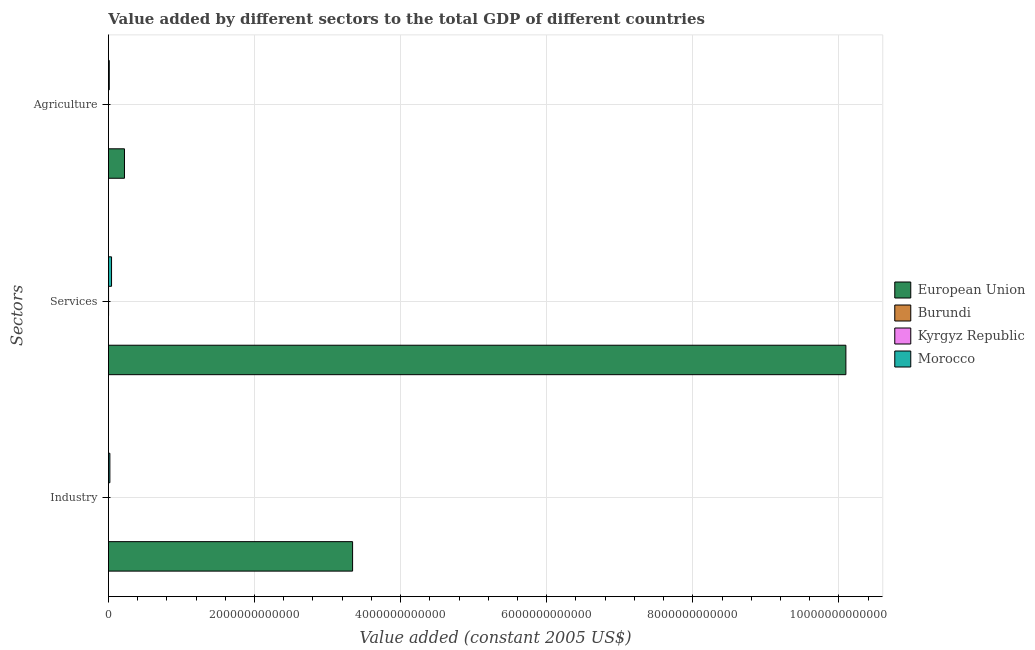How many groups of bars are there?
Offer a very short reply. 3. Are the number of bars per tick equal to the number of legend labels?
Ensure brevity in your answer.  Yes. Are the number of bars on each tick of the Y-axis equal?
Give a very brief answer. Yes. What is the label of the 2nd group of bars from the top?
Offer a very short reply. Services. What is the value added by agricultural sector in Morocco?
Keep it short and to the point. 1.14e+1. Across all countries, what is the maximum value added by industrial sector?
Your answer should be very brief. 3.34e+12. Across all countries, what is the minimum value added by industrial sector?
Offer a terse response. 2.58e+08. In which country was the value added by agricultural sector minimum?
Give a very brief answer. Burundi. What is the total value added by industrial sector in the graph?
Offer a terse response. 3.36e+12. What is the difference between the value added by services in Morocco and that in Kyrgyz Republic?
Ensure brevity in your answer.  4.08e+1. What is the difference between the value added by industrial sector in Kyrgyz Republic and the value added by agricultural sector in European Union?
Give a very brief answer. -2.19e+11. What is the average value added by services per country?
Offer a very short reply. 2.54e+12. What is the difference between the value added by services and value added by industrial sector in Kyrgyz Republic?
Your answer should be very brief. 1.25e+09. In how many countries, is the value added by agricultural sector greater than 6400000000000 US$?
Offer a very short reply. 0. What is the ratio of the value added by industrial sector in European Union to that in Morocco?
Keep it short and to the point. 169.88. Is the value added by industrial sector in Morocco less than that in Burundi?
Your response must be concise. No. What is the difference between the highest and the second highest value added by industrial sector?
Make the answer very short. 3.32e+12. What is the difference between the highest and the lowest value added by agricultural sector?
Make the answer very short. 2.19e+11. What does the 3rd bar from the top in Services represents?
Offer a terse response. Burundi. What does the 4th bar from the bottom in Industry represents?
Provide a short and direct response. Morocco. How many bars are there?
Your answer should be very brief. 12. What is the difference between two consecutive major ticks on the X-axis?
Give a very brief answer. 2.00e+12. Are the values on the major ticks of X-axis written in scientific E-notation?
Your answer should be compact. No. Does the graph contain any zero values?
Your response must be concise. No. Does the graph contain grids?
Offer a terse response. Yes. Where does the legend appear in the graph?
Your response must be concise. Center right. How many legend labels are there?
Ensure brevity in your answer.  4. How are the legend labels stacked?
Your answer should be compact. Vertical. What is the title of the graph?
Your answer should be very brief. Value added by different sectors to the total GDP of different countries. What is the label or title of the X-axis?
Provide a short and direct response. Value added (constant 2005 US$). What is the label or title of the Y-axis?
Your response must be concise. Sectors. What is the Value added (constant 2005 US$) of European Union in Industry?
Ensure brevity in your answer.  3.34e+12. What is the Value added (constant 2005 US$) in Burundi in Industry?
Keep it short and to the point. 2.58e+08. What is the Value added (constant 2005 US$) of Kyrgyz Republic in Industry?
Keep it short and to the point. 5.54e+08. What is the Value added (constant 2005 US$) of Morocco in Industry?
Your answer should be very brief. 1.97e+1. What is the Value added (constant 2005 US$) in European Union in Services?
Keep it short and to the point. 1.01e+13. What is the Value added (constant 2005 US$) of Burundi in Services?
Offer a terse response. 6.34e+08. What is the Value added (constant 2005 US$) of Kyrgyz Republic in Services?
Your answer should be compact. 1.81e+09. What is the Value added (constant 2005 US$) of Morocco in Services?
Provide a short and direct response. 4.26e+1. What is the Value added (constant 2005 US$) of European Union in Agriculture?
Keep it short and to the point. 2.20e+11. What is the Value added (constant 2005 US$) in Burundi in Agriculture?
Offer a terse response. 4.95e+08. What is the Value added (constant 2005 US$) in Kyrgyz Republic in Agriculture?
Ensure brevity in your answer.  6.89e+08. What is the Value added (constant 2005 US$) in Morocco in Agriculture?
Your response must be concise. 1.14e+1. Across all Sectors, what is the maximum Value added (constant 2005 US$) in European Union?
Keep it short and to the point. 1.01e+13. Across all Sectors, what is the maximum Value added (constant 2005 US$) in Burundi?
Offer a very short reply. 6.34e+08. Across all Sectors, what is the maximum Value added (constant 2005 US$) in Kyrgyz Republic?
Provide a succinct answer. 1.81e+09. Across all Sectors, what is the maximum Value added (constant 2005 US$) of Morocco?
Offer a very short reply. 4.26e+1. Across all Sectors, what is the minimum Value added (constant 2005 US$) in European Union?
Give a very brief answer. 2.20e+11. Across all Sectors, what is the minimum Value added (constant 2005 US$) of Burundi?
Your answer should be very brief. 2.58e+08. Across all Sectors, what is the minimum Value added (constant 2005 US$) of Kyrgyz Republic?
Offer a very short reply. 5.54e+08. Across all Sectors, what is the minimum Value added (constant 2005 US$) in Morocco?
Keep it short and to the point. 1.14e+1. What is the total Value added (constant 2005 US$) of European Union in the graph?
Give a very brief answer. 1.37e+13. What is the total Value added (constant 2005 US$) in Burundi in the graph?
Give a very brief answer. 1.39e+09. What is the total Value added (constant 2005 US$) of Kyrgyz Republic in the graph?
Provide a succinct answer. 3.05e+09. What is the total Value added (constant 2005 US$) of Morocco in the graph?
Offer a terse response. 7.37e+1. What is the difference between the Value added (constant 2005 US$) of European Union in Industry and that in Services?
Your answer should be very brief. -6.75e+12. What is the difference between the Value added (constant 2005 US$) of Burundi in Industry and that in Services?
Make the answer very short. -3.76e+08. What is the difference between the Value added (constant 2005 US$) of Kyrgyz Republic in Industry and that in Services?
Keep it short and to the point. -1.25e+09. What is the difference between the Value added (constant 2005 US$) of Morocco in Industry and that in Services?
Provide a succinct answer. -2.29e+1. What is the difference between the Value added (constant 2005 US$) of European Union in Industry and that in Agriculture?
Provide a short and direct response. 3.12e+12. What is the difference between the Value added (constant 2005 US$) in Burundi in Industry and that in Agriculture?
Your answer should be very brief. -2.37e+08. What is the difference between the Value added (constant 2005 US$) of Kyrgyz Republic in Industry and that in Agriculture?
Ensure brevity in your answer.  -1.35e+08. What is the difference between the Value added (constant 2005 US$) in Morocco in Industry and that in Agriculture?
Your answer should be compact. 8.30e+09. What is the difference between the Value added (constant 2005 US$) of European Union in Services and that in Agriculture?
Give a very brief answer. 9.88e+12. What is the difference between the Value added (constant 2005 US$) in Burundi in Services and that in Agriculture?
Ensure brevity in your answer.  1.39e+08. What is the difference between the Value added (constant 2005 US$) in Kyrgyz Republic in Services and that in Agriculture?
Provide a succinct answer. 1.12e+09. What is the difference between the Value added (constant 2005 US$) in Morocco in Services and that in Agriculture?
Offer a very short reply. 3.12e+1. What is the difference between the Value added (constant 2005 US$) of European Union in Industry and the Value added (constant 2005 US$) of Burundi in Services?
Provide a short and direct response. 3.34e+12. What is the difference between the Value added (constant 2005 US$) of European Union in Industry and the Value added (constant 2005 US$) of Kyrgyz Republic in Services?
Ensure brevity in your answer.  3.34e+12. What is the difference between the Value added (constant 2005 US$) of European Union in Industry and the Value added (constant 2005 US$) of Morocco in Services?
Offer a very short reply. 3.30e+12. What is the difference between the Value added (constant 2005 US$) of Burundi in Industry and the Value added (constant 2005 US$) of Kyrgyz Republic in Services?
Your answer should be very brief. -1.55e+09. What is the difference between the Value added (constant 2005 US$) of Burundi in Industry and the Value added (constant 2005 US$) of Morocco in Services?
Offer a terse response. -4.23e+1. What is the difference between the Value added (constant 2005 US$) in Kyrgyz Republic in Industry and the Value added (constant 2005 US$) in Morocco in Services?
Your answer should be very brief. -4.21e+1. What is the difference between the Value added (constant 2005 US$) in European Union in Industry and the Value added (constant 2005 US$) in Burundi in Agriculture?
Provide a succinct answer. 3.34e+12. What is the difference between the Value added (constant 2005 US$) in European Union in Industry and the Value added (constant 2005 US$) in Kyrgyz Republic in Agriculture?
Provide a short and direct response. 3.34e+12. What is the difference between the Value added (constant 2005 US$) of European Union in Industry and the Value added (constant 2005 US$) of Morocco in Agriculture?
Provide a short and direct response. 3.33e+12. What is the difference between the Value added (constant 2005 US$) in Burundi in Industry and the Value added (constant 2005 US$) in Kyrgyz Republic in Agriculture?
Provide a succinct answer. -4.31e+08. What is the difference between the Value added (constant 2005 US$) of Burundi in Industry and the Value added (constant 2005 US$) of Morocco in Agriculture?
Your answer should be very brief. -1.11e+1. What is the difference between the Value added (constant 2005 US$) of Kyrgyz Republic in Industry and the Value added (constant 2005 US$) of Morocco in Agriculture?
Provide a succinct answer. -1.08e+1. What is the difference between the Value added (constant 2005 US$) in European Union in Services and the Value added (constant 2005 US$) in Burundi in Agriculture?
Keep it short and to the point. 1.01e+13. What is the difference between the Value added (constant 2005 US$) of European Union in Services and the Value added (constant 2005 US$) of Kyrgyz Republic in Agriculture?
Make the answer very short. 1.01e+13. What is the difference between the Value added (constant 2005 US$) of European Union in Services and the Value added (constant 2005 US$) of Morocco in Agriculture?
Your answer should be compact. 1.01e+13. What is the difference between the Value added (constant 2005 US$) in Burundi in Services and the Value added (constant 2005 US$) in Kyrgyz Republic in Agriculture?
Ensure brevity in your answer.  -5.46e+07. What is the difference between the Value added (constant 2005 US$) of Burundi in Services and the Value added (constant 2005 US$) of Morocco in Agriculture?
Provide a short and direct response. -1.07e+1. What is the difference between the Value added (constant 2005 US$) of Kyrgyz Republic in Services and the Value added (constant 2005 US$) of Morocco in Agriculture?
Provide a succinct answer. -9.57e+09. What is the average Value added (constant 2005 US$) of European Union per Sectors?
Your answer should be compact. 4.55e+12. What is the average Value added (constant 2005 US$) of Burundi per Sectors?
Offer a very short reply. 4.62e+08. What is the average Value added (constant 2005 US$) in Kyrgyz Republic per Sectors?
Provide a succinct answer. 1.02e+09. What is the average Value added (constant 2005 US$) in Morocco per Sectors?
Provide a short and direct response. 2.46e+1. What is the difference between the Value added (constant 2005 US$) of European Union and Value added (constant 2005 US$) of Burundi in Industry?
Give a very brief answer. 3.34e+12. What is the difference between the Value added (constant 2005 US$) in European Union and Value added (constant 2005 US$) in Kyrgyz Republic in Industry?
Ensure brevity in your answer.  3.34e+12. What is the difference between the Value added (constant 2005 US$) of European Union and Value added (constant 2005 US$) of Morocco in Industry?
Your response must be concise. 3.32e+12. What is the difference between the Value added (constant 2005 US$) of Burundi and Value added (constant 2005 US$) of Kyrgyz Republic in Industry?
Keep it short and to the point. -2.96e+08. What is the difference between the Value added (constant 2005 US$) of Burundi and Value added (constant 2005 US$) of Morocco in Industry?
Offer a very short reply. -1.94e+1. What is the difference between the Value added (constant 2005 US$) of Kyrgyz Republic and Value added (constant 2005 US$) of Morocco in Industry?
Offer a terse response. -1.91e+1. What is the difference between the Value added (constant 2005 US$) of European Union and Value added (constant 2005 US$) of Burundi in Services?
Give a very brief answer. 1.01e+13. What is the difference between the Value added (constant 2005 US$) in European Union and Value added (constant 2005 US$) in Kyrgyz Republic in Services?
Give a very brief answer. 1.01e+13. What is the difference between the Value added (constant 2005 US$) in European Union and Value added (constant 2005 US$) in Morocco in Services?
Your response must be concise. 1.01e+13. What is the difference between the Value added (constant 2005 US$) of Burundi and Value added (constant 2005 US$) of Kyrgyz Republic in Services?
Keep it short and to the point. -1.17e+09. What is the difference between the Value added (constant 2005 US$) in Burundi and Value added (constant 2005 US$) in Morocco in Services?
Your answer should be compact. -4.20e+1. What is the difference between the Value added (constant 2005 US$) in Kyrgyz Republic and Value added (constant 2005 US$) in Morocco in Services?
Offer a terse response. -4.08e+1. What is the difference between the Value added (constant 2005 US$) in European Union and Value added (constant 2005 US$) in Burundi in Agriculture?
Give a very brief answer. 2.19e+11. What is the difference between the Value added (constant 2005 US$) in European Union and Value added (constant 2005 US$) in Kyrgyz Republic in Agriculture?
Keep it short and to the point. 2.19e+11. What is the difference between the Value added (constant 2005 US$) in European Union and Value added (constant 2005 US$) in Morocco in Agriculture?
Provide a short and direct response. 2.08e+11. What is the difference between the Value added (constant 2005 US$) of Burundi and Value added (constant 2005 US$) of Kyrgyz Republic in Agriculture?
Make the answer very short. -1.94e+08. What is the difference between the Value added (constant 2005 US$) in Burundi and Value added (constant 2005 US$) in Morocco in Agriculture?
Provide a succinct answer. -1.09e+1. What is the difference between the Value added (constant 2005 US$) of Kyrgyz Republic and Value added (constant 2005 US$) of Morocco in Agriculture?
Ensure brevity in your answer.  -1.07e+1. What is the ratio of the Value added (constant 2005 US$) of European Union in Industry to that in Services?
Offer a terse response. 0.33. What is the ratio of the Value added (constant 2005 US$) of Burundi in Industry to that in Services?
Your answer should be compact. 0.41. What is the ratio of the Value added (constant 2005 US$) of Kyrgyz Republic in Industry to that in Services?
Ensure brevity in your answer.  0.31. What is the ratio of the Value added (constant 2005 US$) of Morocco in Industry to that in Services?
Give a very brief answer. 0.46. What is the ratio of the Value added (constant 2005 US$) of European Union in Industry to that in Agriculture?
Offer a very short reply. 15.22. What is the ratio of the Value added (constant 2005 US$) of Burundi in Industry to that in Agriculture?
Keep it short and to the point. 0.52. What is the ratio of the Value added (constant 2005 US$) of Kyrgyz Republic in Industry to that in Agriculture?
Provide a short and direct response. 0.8. What is the ratio of the Value added (constant 2005 US$) in Morocco in Industry to that in Agriculture?
Provide a short and direct response. 1.73. What is the ratio of the Value added (constant 2005 US$) of European Union in Services to that in Agriculture?
Make the answer very short. 45.97. What is the ratio of the Value added (constant 2005 US$) of Burundi in Services to that in Agriculture?
Your response must be concise. 1.28. What is the ratio of the Value added (constant 2005 US$) of Kyrgyz Republic in Services to that in Agriculture?
Your response must be concise. 2.62. What is the ratio of the Value added (constant 2005 US$) in Morocco in Services to that in Agriculture?
Keep it short and to the point. 3.74. What is the difference between the highest and the second highest Value added (constant 2005 US$) in European Union?
Give a very brief answer. 6.75e+12. What is the difference between the highest and the second highest Value added (constant 2005 US$) of Burundi?
Give a very brief answer. 1.39e+08. What is the difference between the highest and the second highest Value added (constant 2005 US$) in Kyrgyz Republic?
Provide a succinct answer. 1.12e+09. What is the difference between the highest and the second highest Value added (constant 2005 US$) in Morocco?
Provide a short and direct response. 2.29e+1. What is the difference between the highest and the lowest Value added (constant 2005 US$) of European Union?
Keep it short and to the point. 9.88e+12. What is the difference between the highest and the lowest Value added (constant 2005 US$) of Burundi?
Provide a succinct answer. 3.76e+08. What is the difference between the highest and the lowest Value added (constant 2005 US$) of Kyrgyz Republic?
Keep it short and to the point. 1.25e+09. What is the difference between the highest and the lowest Value added (constant 2005 US$) of Morocco?
Keep it short and to the point. 3.12e+1. 